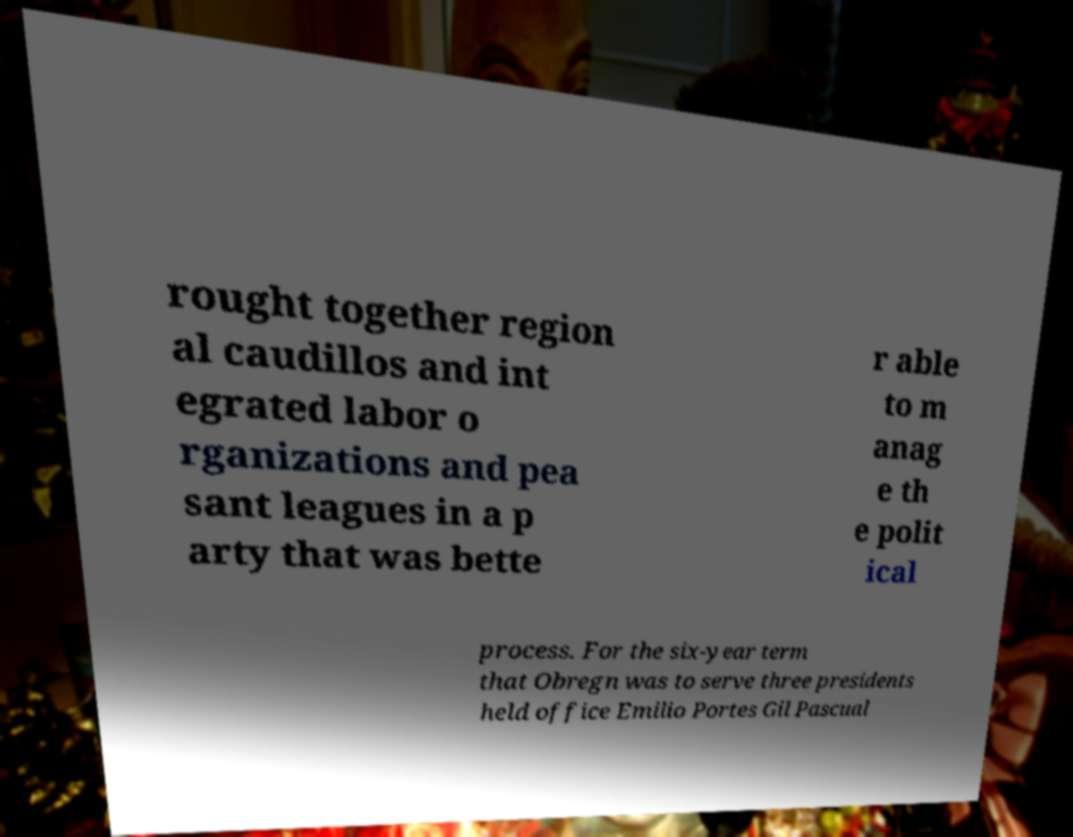I need the written content from this picture converted into text. Can you do that? rought together region al caudillos and int egrated labor o rganizations and pea sant leagues in a p arty that was bette r able to m anag e th e polit ical process. For the six-year term that Obregn was to serve three presidents held office Emilio Portes Gil Pascual 